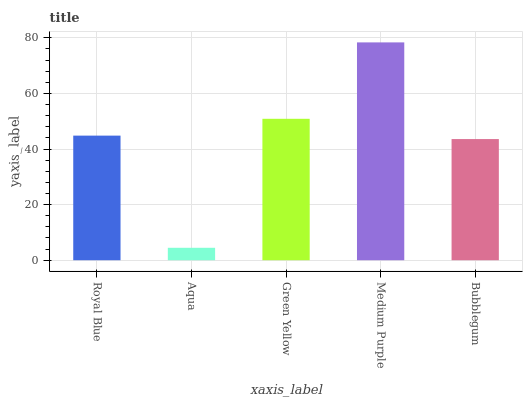Is Aqua the minimum?
Answer yes or no. Yes. Is Medium Purple the maximum?
Answer yes or no. Yes. Is Green Yellow the minimum?
Answer yes or no. No. Is Green Yellow the maximum?
Answer yes or no. No. Is Green Yellow greater than Aqua?
Answer yes or no. Yes. Is Aqua less than Green Yellow?
Answer yes or no. Yes. Is Aqua greater than Green Yellow?
Answer yes or no. No. Is Green Yellow less than Aqua?
Answer yes or no. No. Is Royal Blue the high median?
Answer yes or no. Yes. Is Royal Blue the low median?
Answer yes or no. Yes. Is Aqua the high median?
Answer yes or no. No. Is Bubblegum the low median?
Answer yes or no. No. 